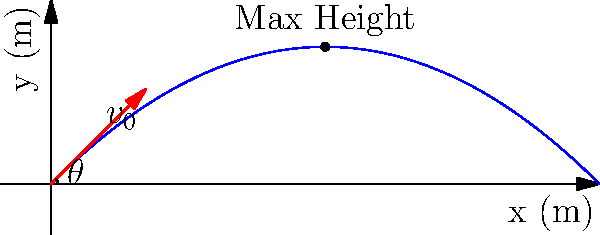In your 2D platformer game, you want to implement a projectile launch feature. The projectile is launched with an initial velocity of 20 m/s at an angle of 45° above the horizontal. Assuming no air resistance, calculate the maximum height reached by the projectile. Use g = 9.8 m/s² for the acceleration due to gravity. To solve this problem, we'll follow these steps:

1) The maximum height is reached when the vertical component of velocity becomes zero. We need to find the time when this occurs and then calculate the height at that time.

2) The vertical component of the initial velocity is:
   $v_{0y} = v_0 \sin(\theta) = 20 \sin(45°) = 20 \cdot \frac{\sqrt{2}}{2} \approx 14.14$ m/s

3) The time to reach the maximum height is when $v_y = 0$:
   $v_y = v_{0y} - gt = 0$
   $t = \frac{v_{0y}}{g} = \frac{14.14}{9.8} \approx 1.44$ seconds

4) Now we can use the equation for displacement in the y-direction:
   $y = v_{0y}t - \frac{1}{2}gt^2$

5) Substituting our values:
   $y = 14.14 \cdot 1.44 - \frac{1}{2} \cdot 9.8 \cdot 1.44^2$
   $y = 20.36 - 10.18 = 10.18$ meters

Therefore, the maximum height reached by the projectile is approximately 10.18 meters.
Answer: 10.18 m 